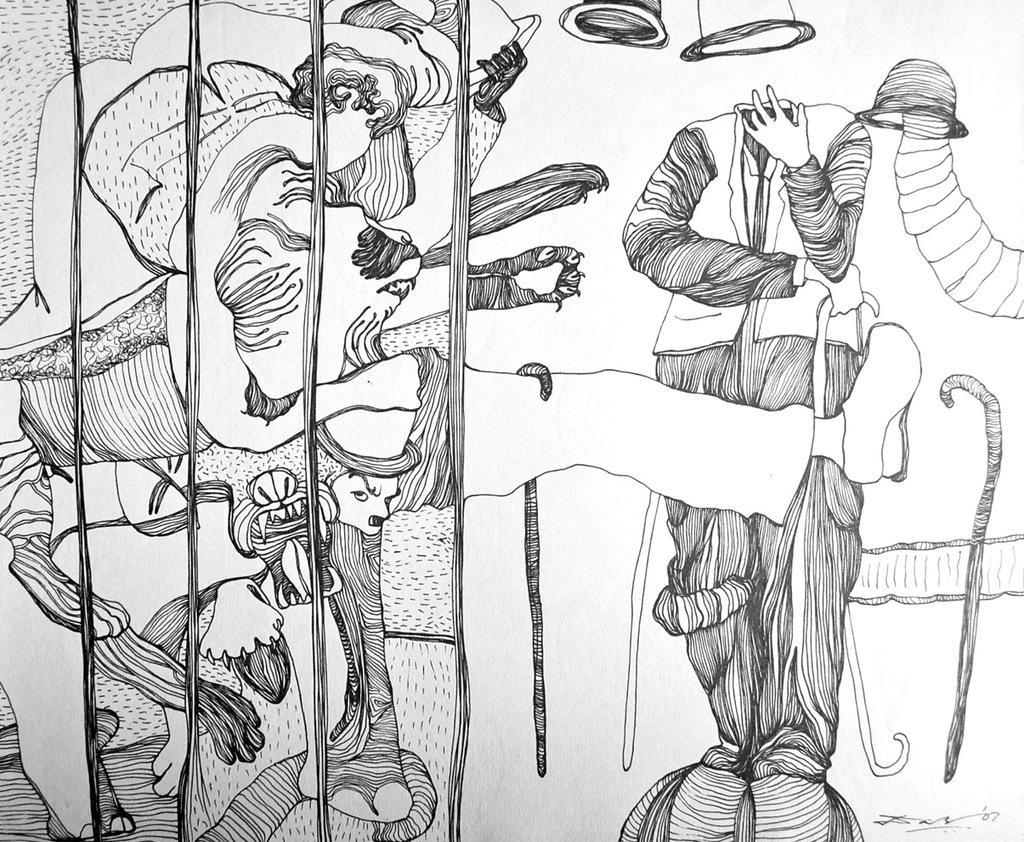Please provide a concise description of this image. In the image there is a sketch of different structures. 